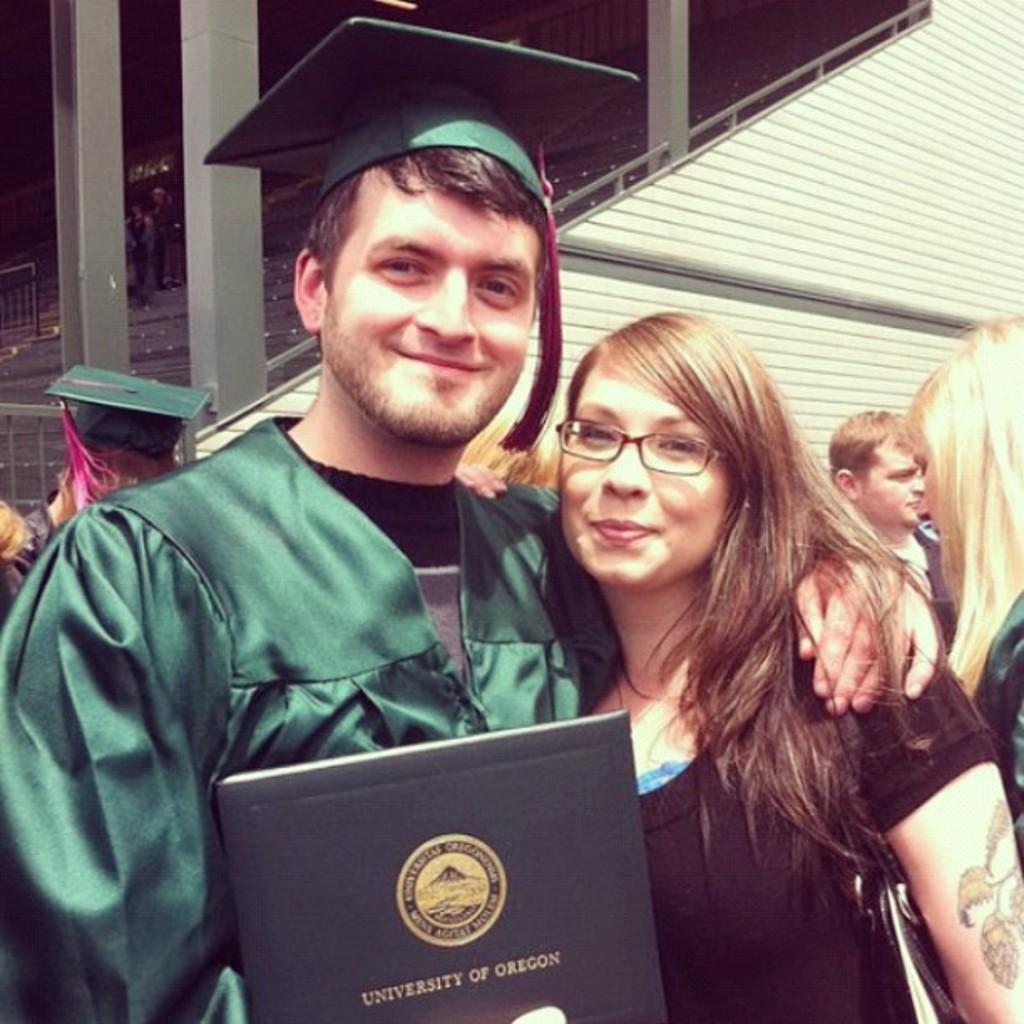In one or two sentences, can you explain what this image depicts? Here I can see a woman and a man are standing, smiling and giving pose for the picture. The man is wearing a coat, cap on the head and holding a book in the hand. In the background, I can see some more people standing. At the top of the image there are few pillars and a wall. 